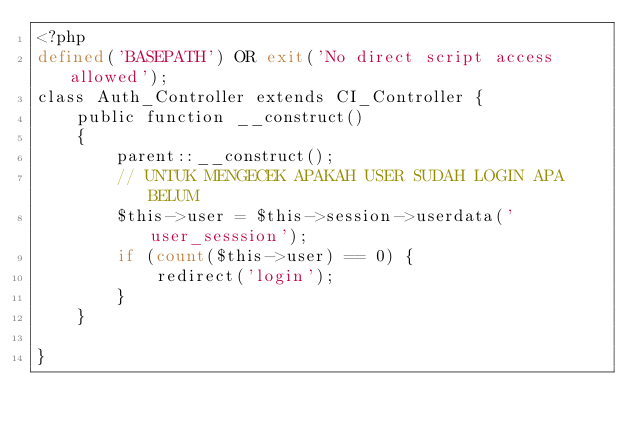<code> <loc_0><loc_0><loc_500><loc_500><_PHP_><?php
defined('BASEPATH') OR exit('No direct script access allowed');
class Auth_Controller extends CI_Controller {
	public function __construct()
	{
		parent::__construct();
		// UNTUK MENGECEK APAKAH USER SUDAH LOGIN APA BELUM
		$this->user = $this->session->userdata('user_sesssion');
		if (count($this->user) == 0) {
			redirect('login');
		}
	}

}
</code> 